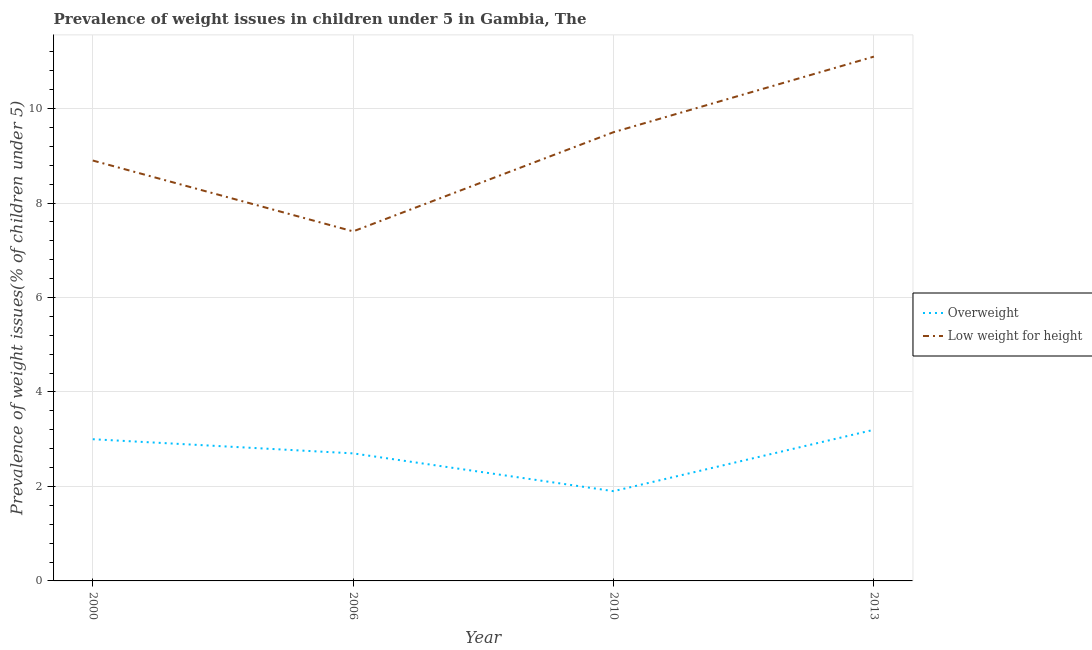How many different coloured lines are there?
Your response must be concise. 2. Is the number of lines equal to the number of legend labels?
Provide a short and direct response. Yes. What is the percentage of underweight children in 2000?
Give a very brief answer. 8.9. Across all years, what is the maximum percentage of underweight children?
Your answer should be compact. 11.1. Across all years, what is the minimum percentage of underweight children?
Your response must be concise. 7.4. In which year was the percentage of underweight children maximum?
Offer a terse response. 2013. In which year was the percentage of underweight children minimum?
Your answer should be very brief. 2006. What is the total percentage of overweight children in the graph?
Keep it short and to the point. 10.8. What is the difference between the percentage of underweight children in 2006 and that in 2013?
Offer a very short reply. -3.7. What is the difference between the percentage of overweight children in 2013 and the percentage of underweight children in 2000?
Your answer should be very brief. -5.7. What is the average percentage of underweight children per year?
Keep it short and to the point. 9.23. In the year 2000, what is the difference between the percentage of overweight children and percentage of underweight children?
Offer a terse response. -5.9. In how many years, is the percentage of underweight children greater than 7.2 %?
Provide a succinct answer. 4. What is the ratio of the percentage of overweight children in 2006 to that in 2013?
Make the answer very short. 0.84. Is the percentage of underweight children in 2000 less than that in 2013?
Keep it short and to the point. Yes. Is the difference between the percentage of underweight children in 2000 and 2010 greater than the difference between the percentage of overweight children in 2000 and 2010?
Your answer should be very brief. No. What is the difference between the highest and the second highest percentage of underweight children?
Your answer should be compact. 1.6. What is the difference between the highest and the lowest percentage of overweight children?
Your answer should be compact. 1.3. In how many years, is the percentage of underweight children greater than the average percentage of underweight children taken over all years?
Provide a succinct answer. 2. Is the sum of the percentage of overweight children in 2000 and 2006 greater than the maximum percentage of underweight children across all years?
Provide a short and direct response. No. How many lines are there?
Offer a very short reply. 2. How many years are there in the graph?
Your answer should be compact. 4. Does the graph contain grids?
Offer a terse response. Yes. Where does the legend appear in the graph?
Provide a short and direct response. Center right. How many legend labels are there?
Offer a very short reply. 2. What is the title of the graph?
Your response must be concise. Prevalence of weight issues in children under 5 in Gambia, The. What is the label or title of the X-axis?
Make the answer very short. Year. What is the label or title of the Y-axis?
Make the answer very short. Prevalence of weight issues(% of children under 5). What is the Prevalence of weight issues(% of children under 5) of Low weight for height in 2000?
Your answer should be very brief. 8.9. What is the Prevalence of weight issues(% of children under 5) of Overweight in 2006?
Your answer should be compact. 2.7. What is the Prevalence of weight issues(% of children under 5) in Low weight for height in 2006?
Give a very brief answer. 7.4. What is the Prevalence of weight issues(% of children under 5) of Overweight in 2010?
Your answer should be compact. 1.9. What is the Prevalence of weight issues(% of children under 5) of Low weight for height in 2010?
Your answer should be very brief. 9.5. What is the Prevalence of weight issues(% of children under 5) of Overweight in 2013?
Keep it short and to the point. 3.2. What is the Prevalence of weight issues(% of children under 5) in Low weight for height in 2013?
Your answer should be very brief. 11.1. Across all years, what is the maximum Prevalence of weight issues(% of children under 5) in Overweight?
Ensure brevity in your answer.  3.2. Across all years, what is the maximum Prevalence of weight issues(% of children under 5) in Low weight for height?
Keep it short and to the point. 11.1. Across all years, what is the minimum Prevalence of weight issues(% of children under 5) of Overweight?
Ensure brevity in your answer.  1.9. Across all years, what is the minimum Prevalence of weight issues(% of children under 5) in Low weight for height?
Your answer should be very brief. 7.4. What is the total Prevalence of weight issues(% of children under 5) in Low weight for height in the graph?
Your answer should be very brief. 36.9. What is the difference between the Prevalence of weight issues(% of children under 5) in Overweight in 2000 and that in 2006?
Give a very brief answer. 0.3. What is the difference between the Prevalence of weight issues(% of children under 5) of Low weight for height in 2000 and that in 2006?
Your answer should be compact. 1.5. What is the difference between the Prevalence of weight issues(% of children under 5) in Overweight in 2000 and that in 2010?
Your answer should be compact. 1.1. What is the difference between the Prevalence of weight issues(% of children under 5) of Low weight for height in 2000 and that in 2010?
Offer a very short reply. -0.6. What is the difference between the Prevalence of weight issues(% of children under 5) of Overweight in 2006 and that in 2010?
Provide a short and direct response. 0.8. What is the difference between the Prevalence of weight issues(% of children under 5) in Low weight for height in 2006 and that in 2013?
Keep it short and to the point. -3.7. What is the difference between the Prevalence of weight issues(% of children under 5) of Low weight for height in 2010 and that in 2013?
Provide a succinct answer. -1.6. What is the difference between the Prevalence of weight issues(% of children under 5) of Overweight in 2000 and the Prevalence of weight issues(% of children under 5) of Low weight for height in 2006?
Make the answer very short. -4.4. What is the difference between the Prevalence of weight issues(% of children under 5) of Overweight in 2000 and the Prevalence of weight issues(% of children under 5) of Low weight for height in 2013?
Offer a terse response. -8.1. What is the average Prevalence of weight issues(% of children under 5) in Overweight per year?
Provide a short and direct response. 2.7. What is the average Prevalence of weight issues(% of children under 5) of Low weight for height per year?
Keep it short and to the point. 9.22. In the year 2006, what is the difference between the Prevalence of weight issues(% of children under 5) in Overweight and Prevalence of weight issues(% of children under 5) in Low weight for height?
Provide a succinct answer. -4.7. In the year 2010, what is the difference between the Prevalence of weight issues(% of children under 5) of Overweight and Prevalence of weight issues(% of children under 5) of Low weight for height?
Your answer should be very brief. -7.6. What is the ratio of the Prevalence of weight issues(% of children under 5) in Overweight in 2000 to that in 2006?
Provide a succinct answer. 1.11. What is the ratio of the Prevalence of weight issues(% of children under 5) of Low weight for height in 2000 to that in 2006?
Offer a terse response. 1.2. What is the ratio of the Prevalence of weight issues(% of children under 5) in Overweight in 2000 to that in 2010?
Offer a terse response. 1.58. What is the ratio of the Prevalence of weight issues(% of children under 5) of Low weight for height in 2000 to that in 2010?
Make the answer very short. 0.94. What is the ratio of the Prevalence of weight issues(% of children under 5) of Low weight for height in 2000 to that in 2013?
Your answer should be compact. 0.8. What is the ratio of the Prevalence of weight issues(% of children under 5) of Overweight in 2006 to that in 2010?
Your answer should be compact. 1.42. What is the ratio of the Prevalence of weight issues(% of children under 5) of Low weight for height in 2006 to that in 2010?
Keep it short and to the point. 0.78. What is the ratio of the Prevalence of weight issues(% of children under 5) of Overweight in 2006 to that in 2013?
Give a very brief answer. 0.84. What is the ratio of the Prevalence of weight issues(% of children under 5) of Overweight in 2010 to that in 2013?
Ensure brevity in your answer.  0.59. What is the ratio of the Prevalence of weight issues(% of children under 5) of Low weight for height in 2010 to that in 2013?
Make the answer very short. 0.86. What is the difference between the highest and the second highest Prevalence of weight issues(% of children under 5) of Low weight for height?
Ensure brevity in your answer.  1.6. 